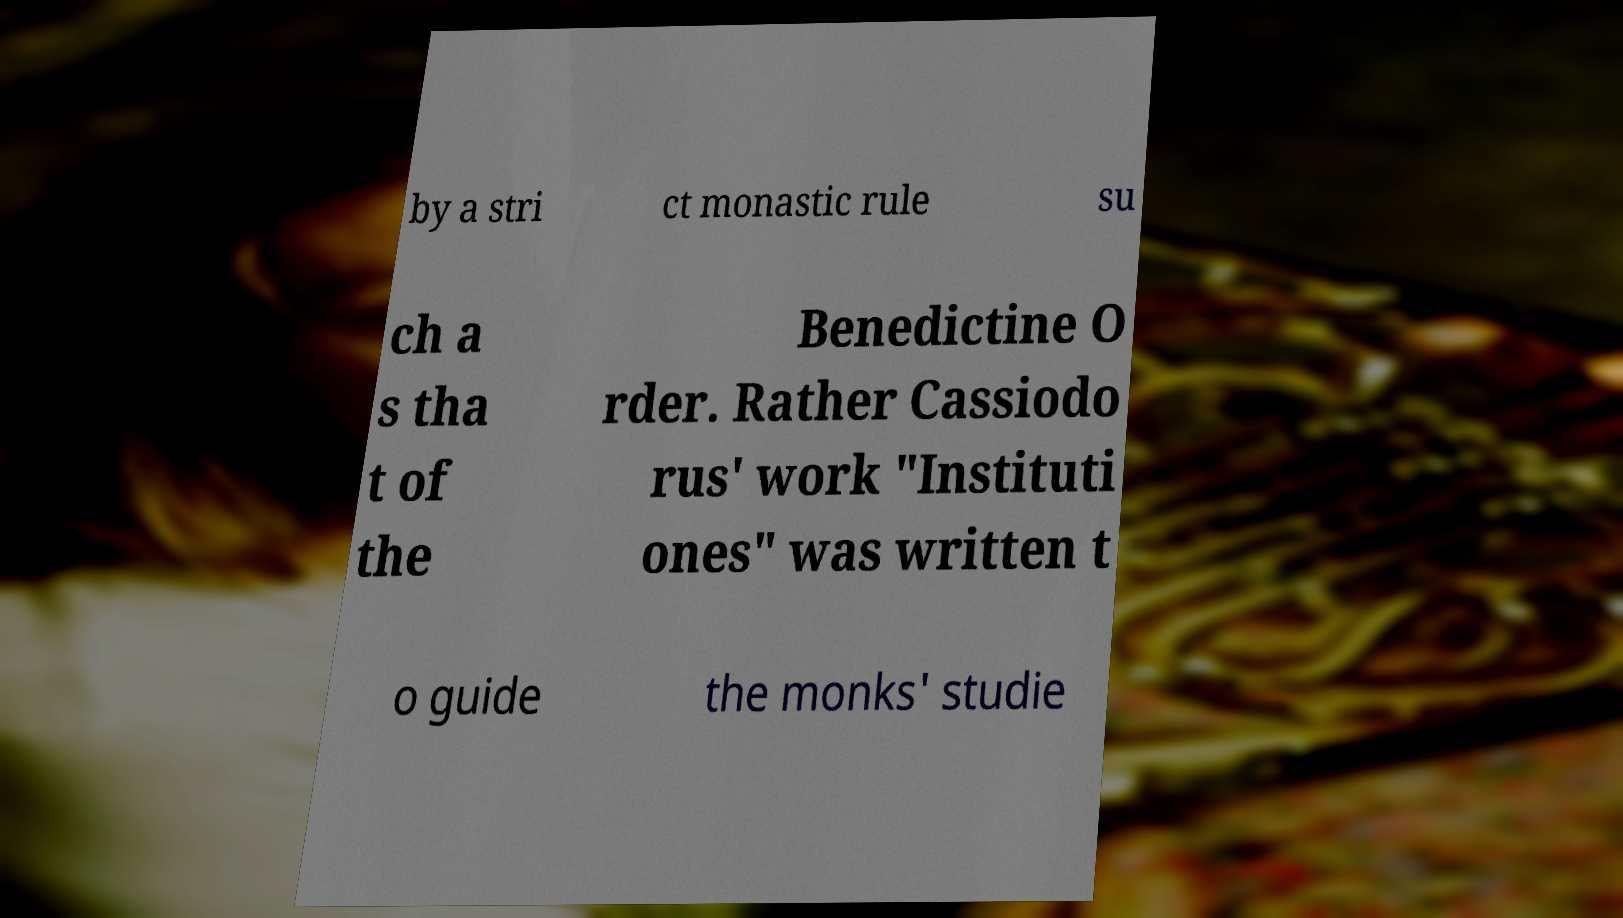For documentation purposes, I need the text within this image transcribed. Could you provide that? by a stri ct monastic rule su ch a s tha t of the Benedictine O rder. Rather Cassiodo rus' work "Instituti ones" was written t o guide the monks' studie 